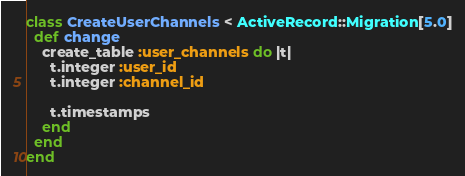Convert code to text. <code><loc_0><loc_0><loc_500><loc_500><_Ruby_>class CreateUserChannels < ActiveRecord::Migration[5.0]
  def change
    create_table :user_channels do |t|
      t.integer :user_id
      t.integer :channel_id

      t.timestamps
    end
  end
end
</code> 